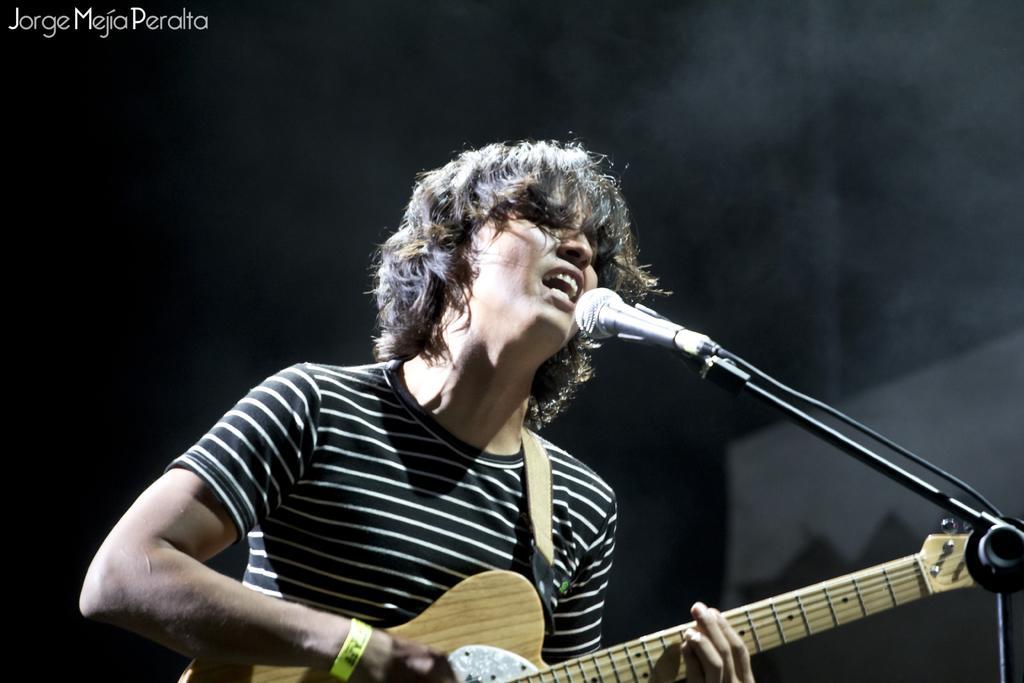How would you summarize this image in a sentence or two? This pictures seems to be of inside. In the center there is a man wearing black color t-shirt, playing guitar and singing. On the right there is a microphone attached to the stand. In the background we can see a wall and there is a watermark on the picture. 